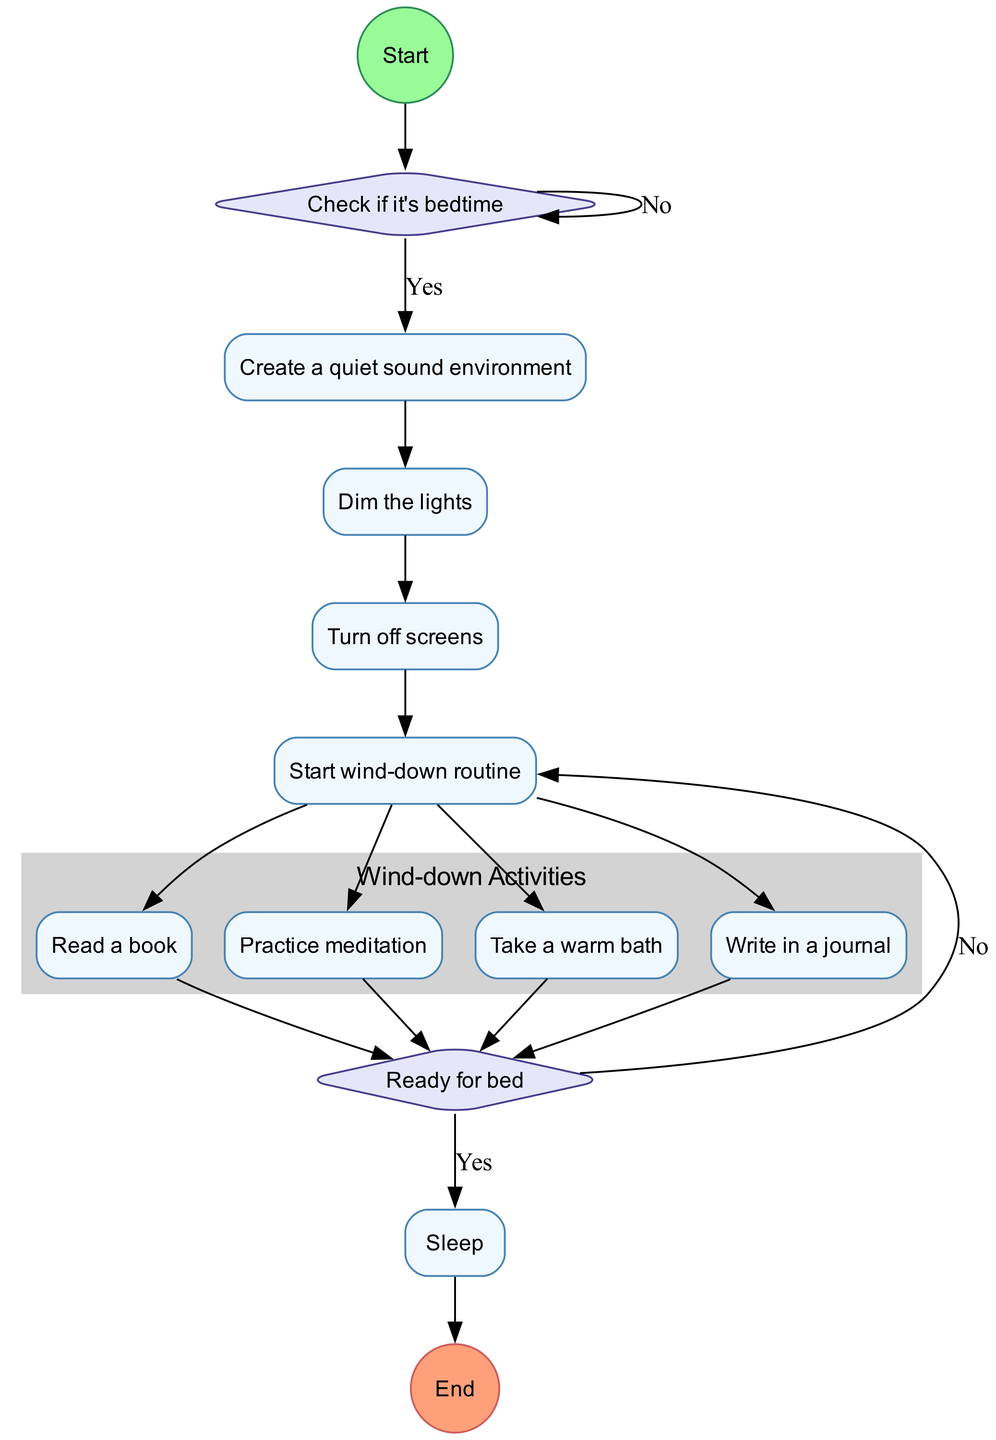What is the first activity in the routine? The diagram starts with the node labeled "Check if it's bedtime," indicating that it is the first activity in the sequence.
Answer: Check if it's bedtime What follows after creating a quiet sound environment? After the "Create a quiet sound environment" activity, the next activity in the flow is "Dim the lights."
Answer: Dim the lights How many options do participants have in the wind-down routine? The "Start wind-down routine" leads to four separate activities: "Read a book," "Practice meditation," "Take a warm bath," and "Write in a journal." Thus, there are four options.
Answer: 4 What happens when a participant is not ready for bed? If the participant is not ready for bed, as indicated by the decision labeled "Ready for bed," they are redirected back to the "Start wind-down routine" node to continue with wind-down activities.
Answer: Start wind-down routine Which activity comes last in the sequence? The final activity in the flow, after being ready for bed, is "Sleep," which is followed by the end event labeled "End."
Answer: Sleep What is the total number of activities listed in the diagram? The diagram includes five activities before reaching the "Ready for bed" decision: "Create a quiet sound environment," "Dim the lights," "Turn off screens," "Start wind-down routine," and the four wind-down activities. Therefore, there are nine activities in total.
Answer: 9 What signifies the completion of the night-time routine? The completion is signified by the end event labeled "End," which occurs after transitioning from the "Sleep" activity.
Answer: End Which two nodes are connected by the decision labeled "Yes"? The "Ready for bed" decision labeled "Yes" connects "Ready for bed" and "Sleep," indicating that if the participant is ready, they proceed to sleep.
Answer: Ready for bed and Sleep 